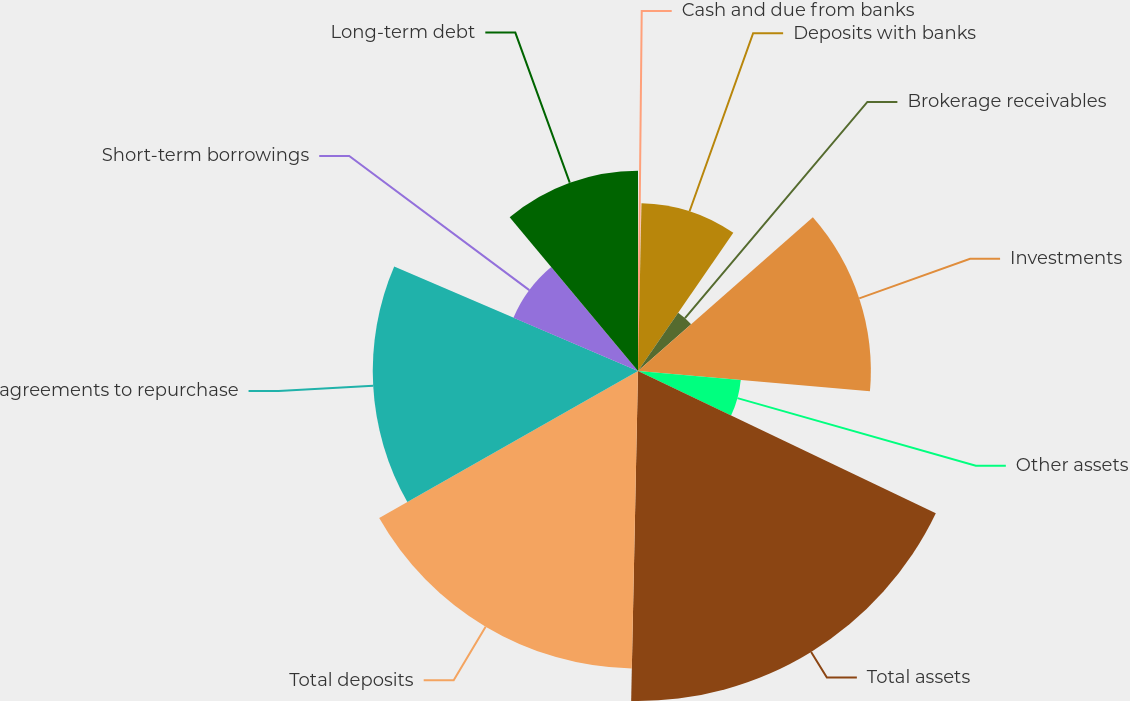<chart> <loc_0><loc_0><loc_500><loc_500><pie_chart><fcel>Cash and due from banks<fcel>Deposits with banks<fcel>Brokerage receivables<fcel>Investments<fcel>Other assets<fcel>Total assets<fcel>Total deposits<fcel>agreements to repurchase<fcel>Short-term borrowings<fcel>Long-term debt<nl><fcel>0.33%<fcel>9.28%<fcel>3.91%<fcel>12.87%<fcel>5.7%<fcel>18.24%<fcel>16.45%<fcel>14.66%<fcel>7.49%<fcel>11.07%<nl></chart> 